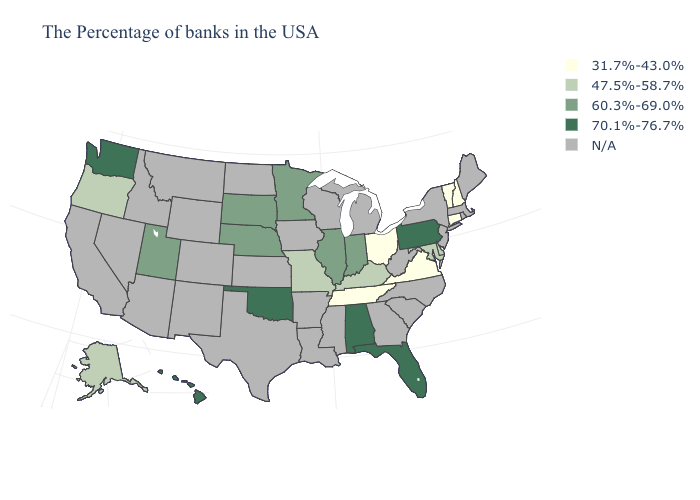What is the lowest value in the USA?
Short answer required. 31.7%-43.0%. What is the value of New York?
Be succinct. N/A. What is the lowest value in the Northeast?
Quick response, please. 31.7%-43.0%. Name the states that have a value in the range N/A?
Quick response, please. Maine, Massachusetts, Rhode Island, New York, New Jersey, North Carolina, South Carolina, West Virginia, Georgia, Michigan, Wisconsin, Mississippi, Louisiana, Arkansas, Iowa, Kansas, Texas, North Dakota, Wyoming, Colorado, New Mexico, Montana, Arizona, Idaho, Nevada, California. Name the states that have a value in the range 31.7%-43.0%?
Write a very short answer. New Hampshire, Vermont, Connecticut, Virginia, Ohio, Tennessee. What is the highest value in the USA?
Be succinct. 70.1%-76.7%. What is the value of Indiana?
Short answer required. 60.3%-69.0%. Does the map have missing data?
Give a very brief answer. Yes. Does the map have missing data?
Give a very brief answer. Yes. Name the states that have a value in the range 60.3%-69.0%?
Keep it brief. Indiana, Illinois, Minnesota, Nebraska, South Dakota, Utah. Name the states that have a value in the range N/A?
Short answer required. Maine, Massachusetts, Rhode Island, New York, New Jersey, North Carolina, South Carolina, West Virginia, Georgia, Michigan, Wisconsin, Mississippi, Louisiana, Arkansas, Iowa, Kansas, Texas, North Dakota, Wyoming, Colorado, New Mexico, Montana, Arizona, Idaho, Nevada, California. Does the map have missing data?
Quick response, please. Yes. 